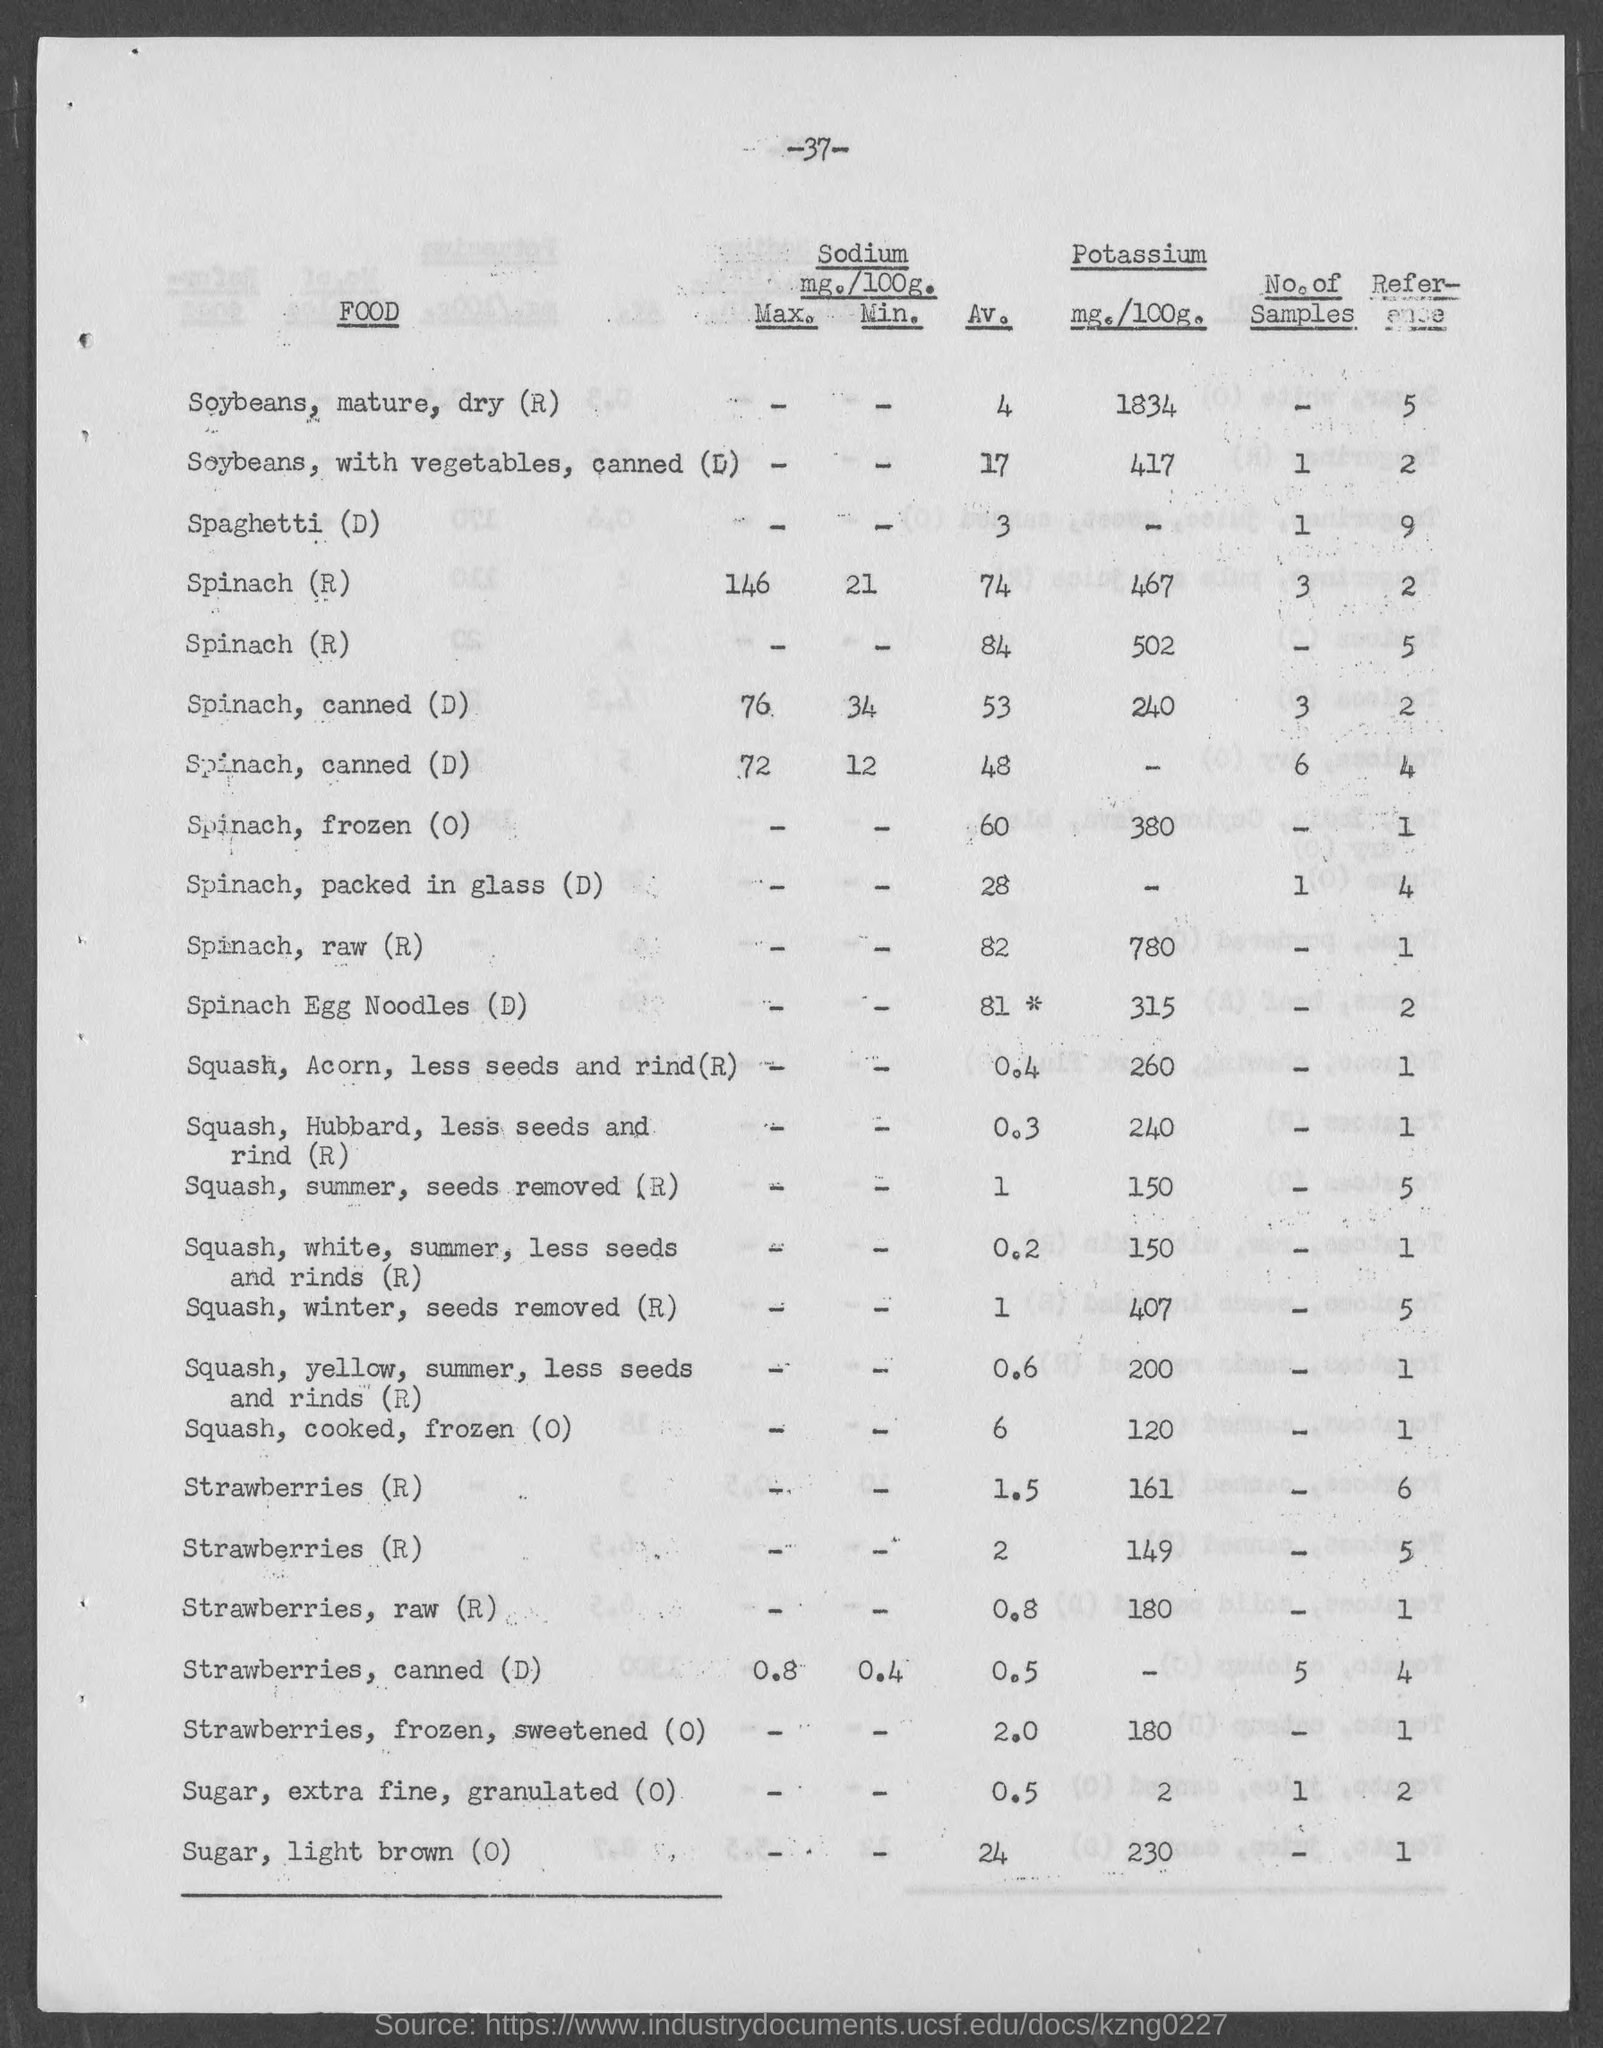What are some potential health benefits of consuming foods high in Potassium? Foods high in Potassium, such as winter squash and spinach, may help maintain optimal blood pressure, reduce the risk of stroke, prevent osteoporosis and kidney stones, and possibly reduce the occurrence of muscle cramping. 